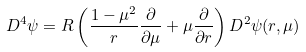Convert formula to latex. <formula><loc_0><loc_0><loc_500><loc_500>D ^ { 4 } \psi = R \left ( \frac { 1 - \mu ^ { 2 } } { r } \frac { \partial } { \partial \mu } + \mu \frac { \partial } { \partial r } \right ) D ^ { 2 } \psi ( r , \mu )</formula> 